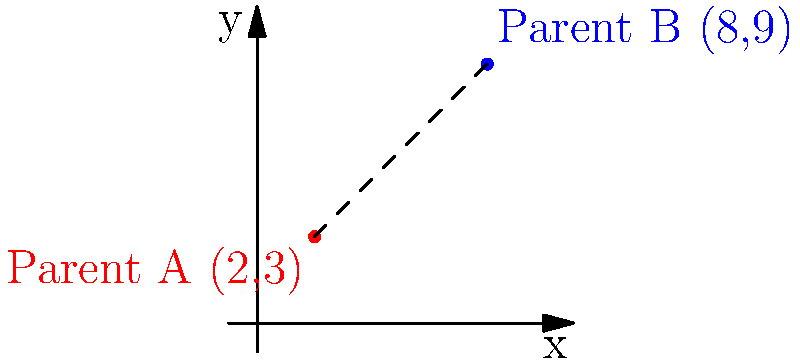In a family, two parents' moral stances are represented by points on a coordinate plane. Parent A's stance is at point (2,3), while Parent B's stance is at (8,9). Calculate the distance between their moral positions to determine how closely aligned their values are. Round your answer to two decimal places. To find the distance between two points on a coordinate plane, we can use the distance formula:

$$d = \sqrt{(x_2-x_1)^2 + (y_2-y_1)^2}$$

Where $(x_1,y_1)$ represents the coordinates of the first point and $(x_2,y_2)$ represents the coordinates of the second point.

Let's plug in our values:
$(x_1,y_1) = (2,3)$ for Parent A
$(x_2,y_2) = (8,9)$ for Parent B

Now, let's calculate:

1) $d = \sqrt{(8-2)^2 + (9-3)^2}$

2) $d = \sqrt{6^2 + 6^2}$

3) $d = \sqrt{36 + 36}$

4) $d = \sqrt{72}$

5) $d \approx 8.4853$

Rounding to two decimal places, we get 8.49.

This distance represents how far apart the parents' moral stances are. A smaller distance would indicate more closely aligned values.
Answer: 8.49 